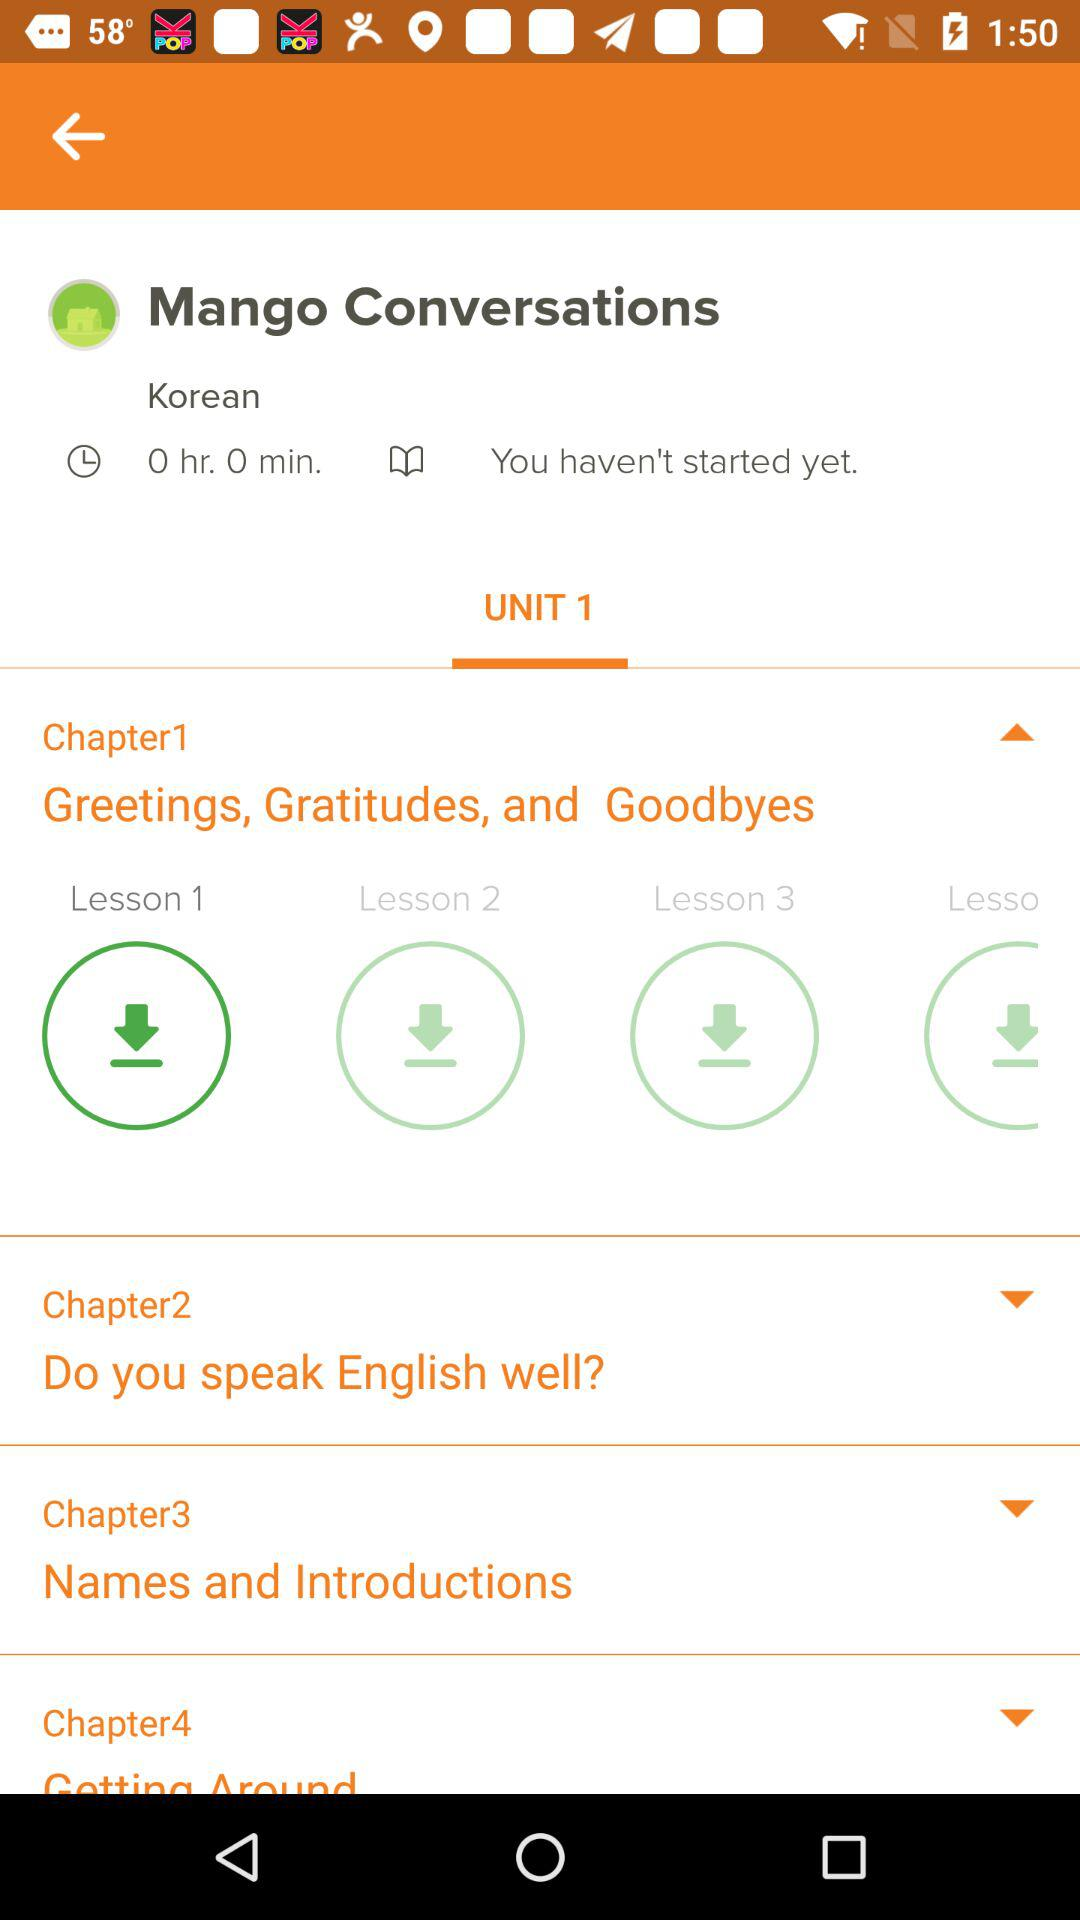What is the name of Chapter 1? The name of Chapter 1 is "Greetings, Gratitudes, and Goodbyes". 